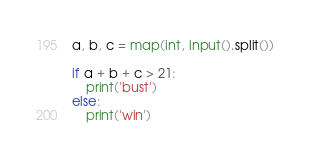<code> <loc_0><loc_0><loc_500><loc_500><_Python_>a, b, c = map(int, input().split())

if a + b + c > 21:
    print('bust')
else:
    print('win')</code> 